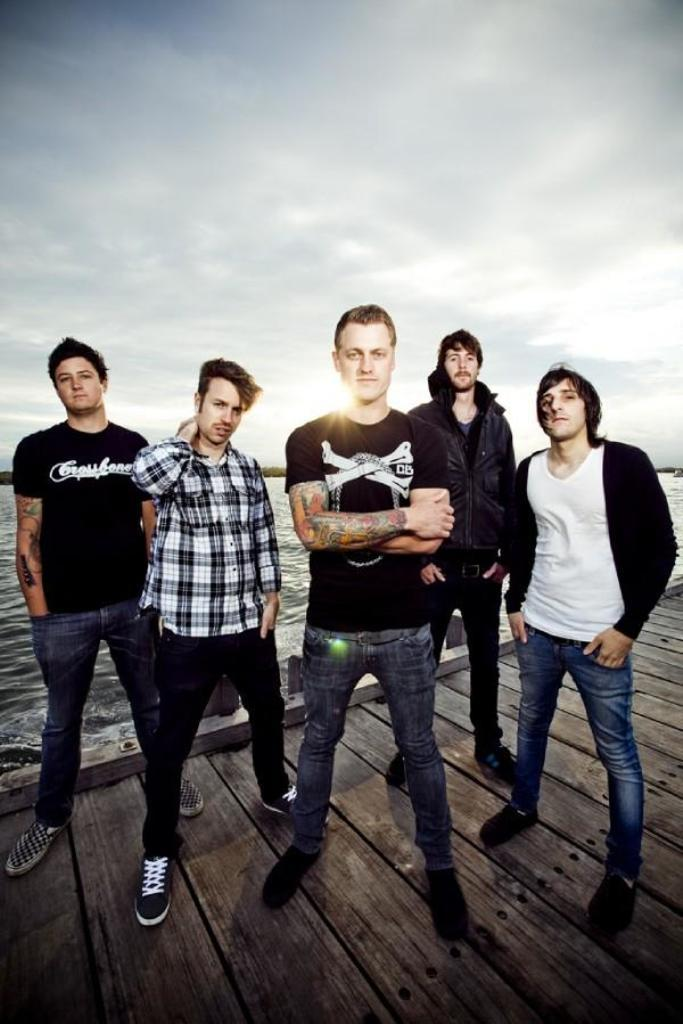How many people are in the image? There is a group of people in the image. What is the surface that the people are standing on? The people are standing on a wooden platform. What can be seen in the background of the image? Water and the sky are visible in the background of the image. What type of goldfish can be seen swimming in the water in the image? There are no goldfish visible in the image; only water is present in the background. How does the snake react to the people standing on the wooden platform in the image? There is no snake present in the image, so it cannot react to the people on the platform. 